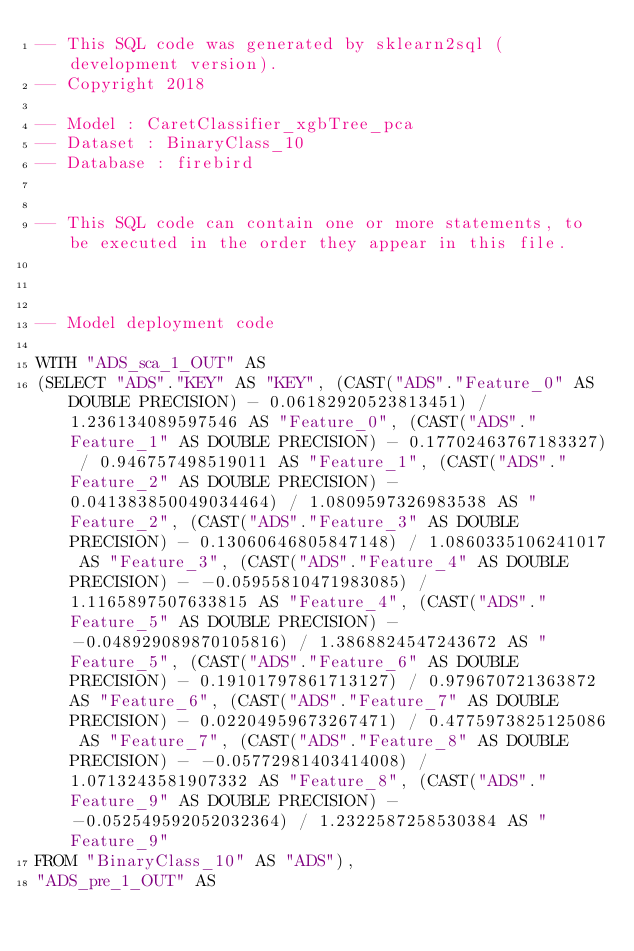Convert code to text. <code><loc_0><loc_0><loc_500><loc_500><_SQL_>-- This SQL code was generated by sklearn2sql (development version).
-- Copyright 2018

-- Model : CaretClassifier_xgbTree_pca
-- Dataset : BinaryClass_10
-- Database : firebird


-- This SQL code can contain one or more statements, to be executed in the order they appear in this file.



-- Model deployment code

WITH "ADS_sca_1_OUT" AS 
(SELECT "ADS"."KEY" AS "KEY", (CAST("ADS"."Feature_0" AS DOUBLE PRECISION) - 0.06182920523813451) / 1.236134089597546 AS "Feature_0", (CAST("ADS"."Feature_1" AS DOUBLE PRECISION) - 0.17702463767183327) / 0.946757498519011 AS "Feature_1", (CAST("ADS"."Feature_2" AS DOUBLE PRECISION) - 0.041383850049034464) / 1.0809597326983538 AS "Feature_2", (CAST("ADS"."Feature_3" AS DOUBLE PRECISION) - 0.13060646805847148) / 1.0860335106241017 AS "Feature_3", (CAST("ADS"."Feature_4" AS DOUBLE PRECISION) - -0.05955810471983085) / 1.1165897507633815 AS "Feature_4", (CAST("ADS"."Feature_5" AS DOUBLE PRECISION) - -0.048929089870105816) / 1.3868824547243672 AS "Feature_5", (CAST("ADS"."Feature_6" AS DOUBLE PRECISION) - 0.19101797861713127) / 0.979670721363872 AS "Feature_6", (CAST("ADS"."Feature_7" AS DOUBLE PRECISION) - 0.02204959673267471) / 0.4775973825125086 AS "Feature_7", (CAST("ADS"."Feature_8" AS DOUBLE PRECISION) - -0.05772981403414008) / 1.0713243581907332 AS "Feature_8", (CAST("ADS"."Feature_9" AS DOUBLE PRECISION) - -0.052549592052032364) / 1.2322587258530384 AS "Feature_9" 
FROM "BinaryClass_10" AS "ADS"), 
"ADS_pre_1_OUT" AS </code> 